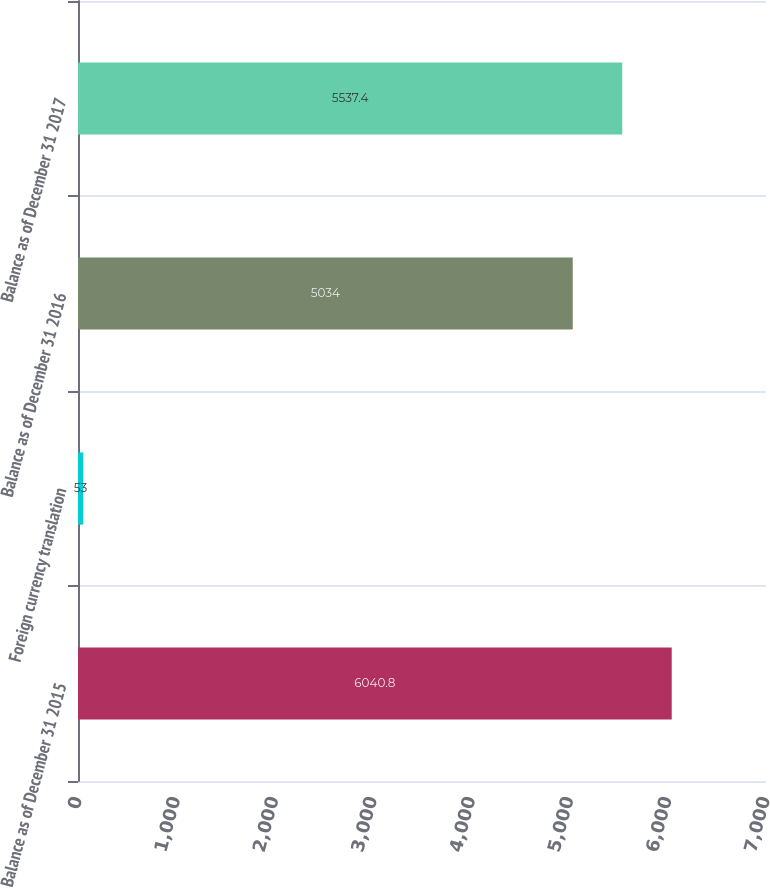Convert chart. <chart><loc_0><loc_0><loc_500><loc_500><bar_chart><fcel>Balance as of December 31 2015<fcel>Foreign currency translation<fcel>Balance as of December 31 2016<fcel>Balance as of December 31 2017<nl><fcel>6040.8<fcel>53<fcel>5034<fcel>5537.4<nl></chart> 